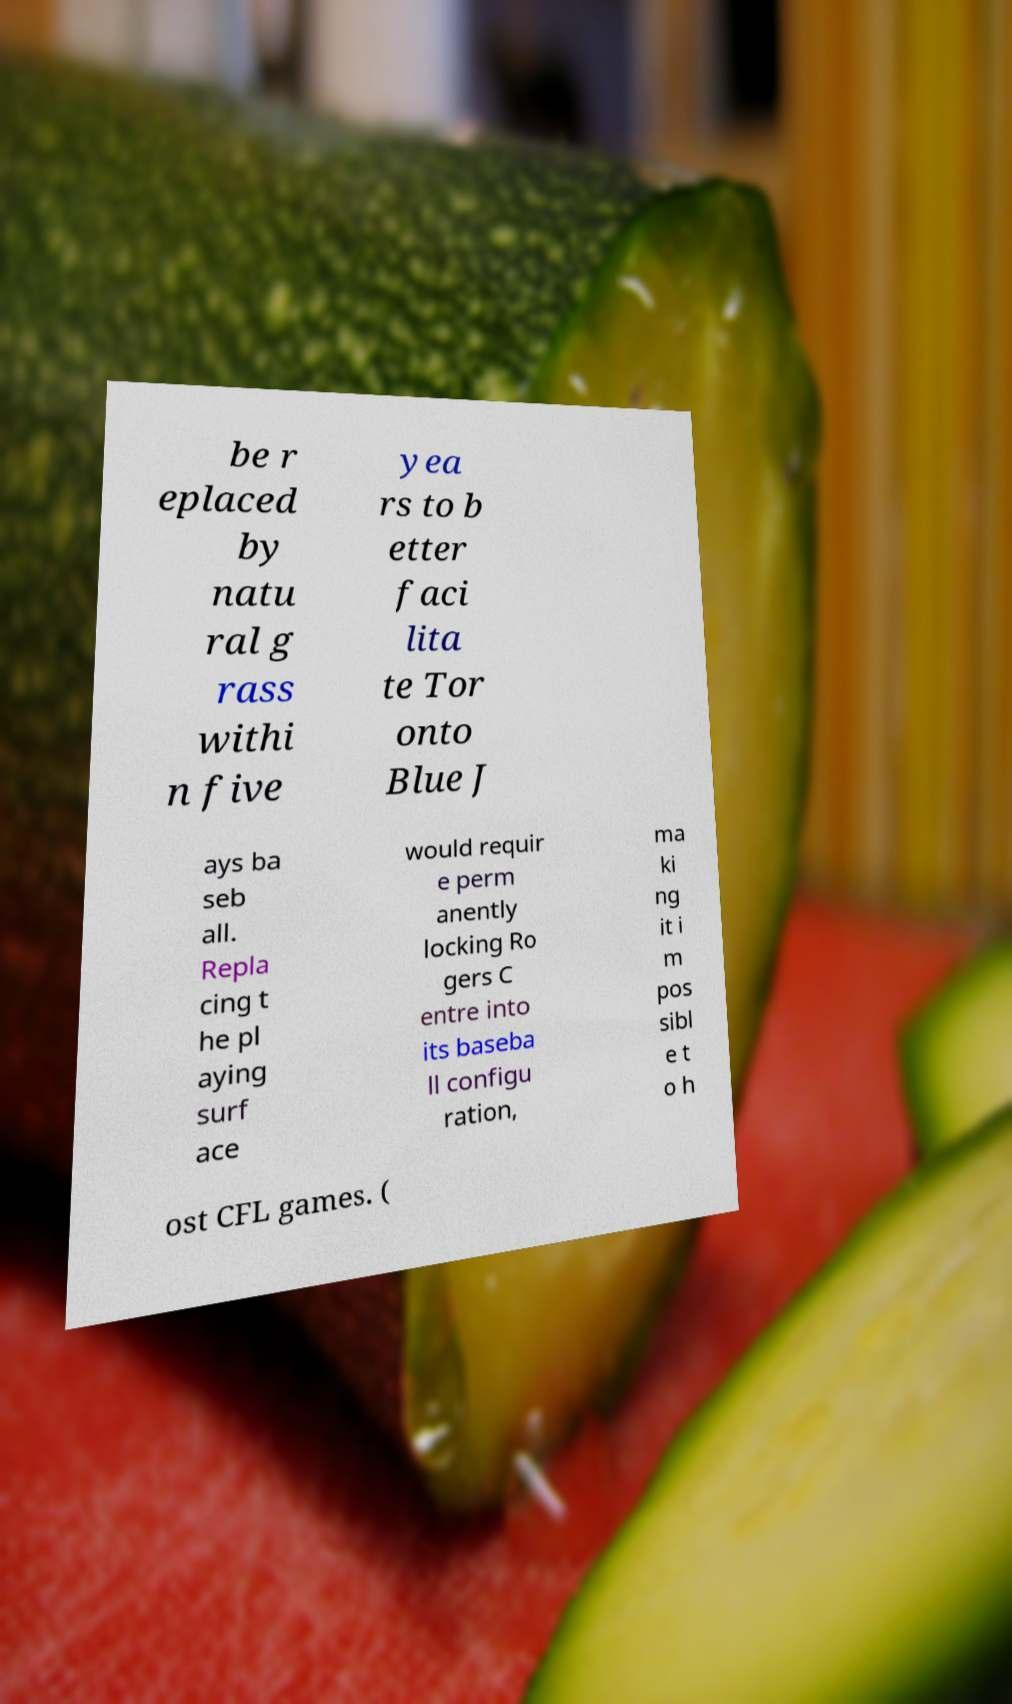For documentation purposes, I need the text within this image transcribed. Could you provide that? be r eplaced by natu ral g rass withi n five yea rs to b etter faci lita te Tor onto Blue J ays ba seb all. Repla cing t he pl aying surf ace would requir e perm anently locking Ro gers C entre into its baseba ll configu ration, ma ki ng it i m pos sibl e t o h ost CFL games. ( 